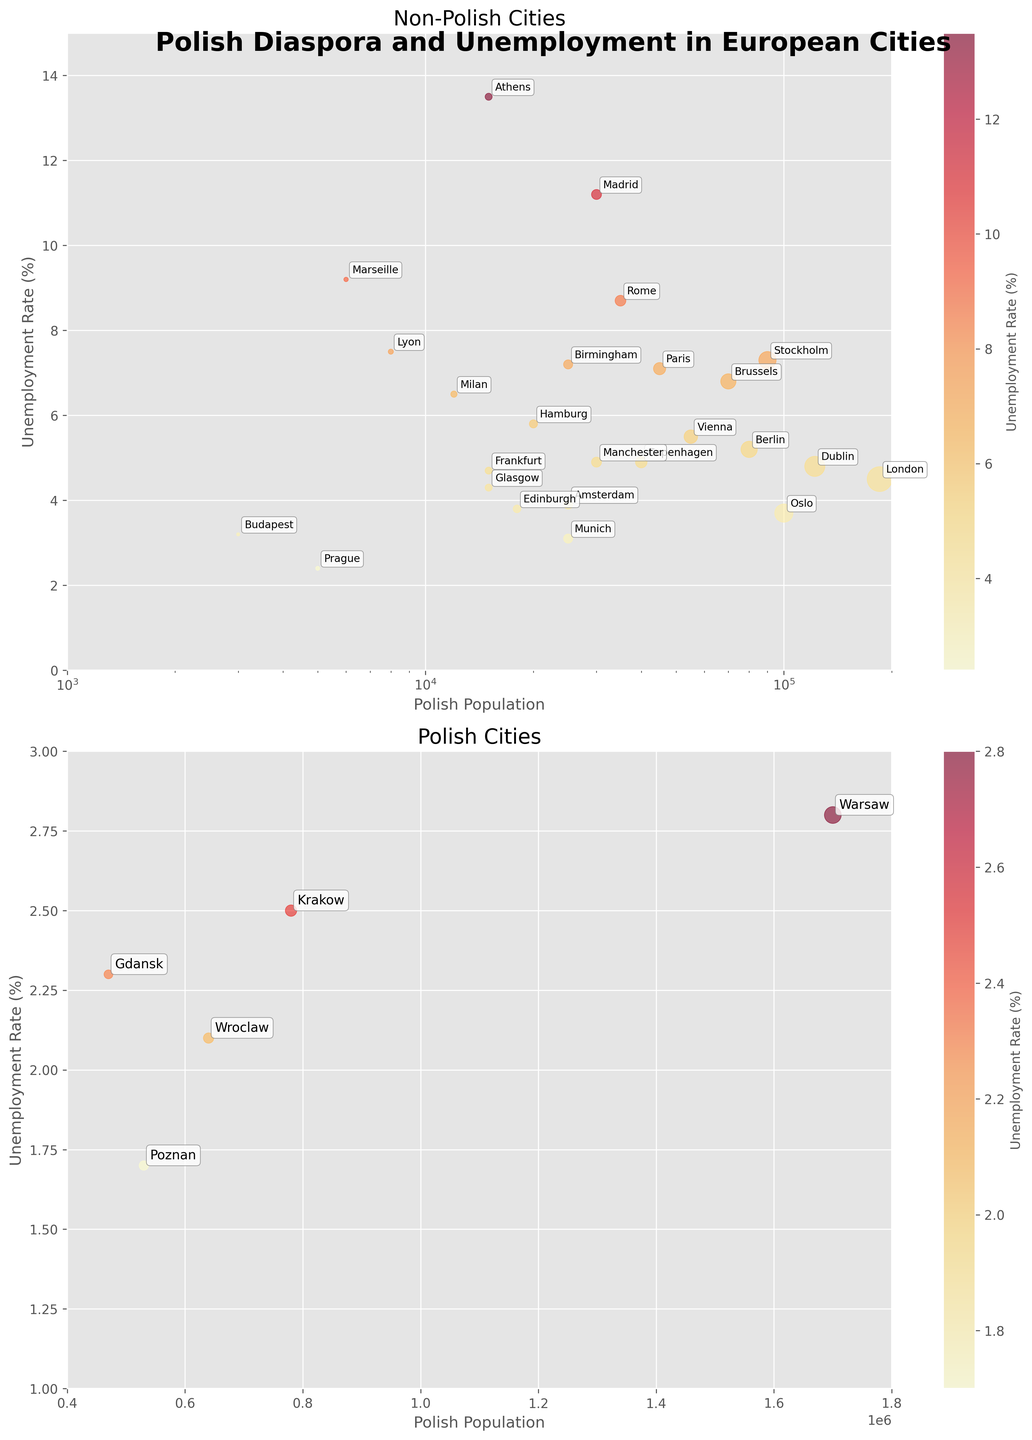What's the city with the highest Polish population outside of Poland? Refer to the non-Polish cities subplot. Notice the city with the largest circle among them, which corresponds to the highest Polish population. That city is London.
Answer: London Which city in Poland has the lowest unemployment rate? In the Polish cities subplot, find the city with the lowest position on the y-axis as this represents the lowest unemployment rate. The city is Poznan.
Answer: Poznan How does the unemployment rate in Berlin compare to that in Amsterdam? Look at the y-axis values for Berlin and Amsterdam in the non-Polish cities subplot. Berlin has an unemployment rate of 5.2%, while Amsterdam has 3.9%. Therefore, Berlin's rate is higher.
Answer: Berlin's rate is higher Is there any Polish city with an unemployment rate above 3%? Examine the Polish cities subplot. Notice that all city points lie within the range of 1-3% on the y-axis, indicating that none have an unemployment rate above 3%.
Answer: No Which city has the highest unemployment rate among non-Polish cities with a Polish population above 50,000? In the non-Polish cities subplot, identify cities above 50,000 on the x-axis. Among these, check the city with the highest position on the y-axis. The city is Athens with an unemployment rate of 13.5%.
Answer: Athens Compare the unemployment rates of Warsaw and Paris. Compare the y-axis values for Warsaw in the Polish cities subplot and Paris in the non-Polish cities subplot. Warsaw has an unemployment rate of 2.8%, while Paris has 7.1%. Therefore, Paris has a higher unemployment rate.
Answer: Paris has a higher rate What is the common unemployment rate range seen in non-Polish cities with a Polish population between 20,000 and 40,000? Focus on the non-Polish cities subplot, locating cities between 20,000 and 40,000 on the x-axis, and observe their distribution on the y-axis. Rates range from 3.8% (Edinburgh) to 5.8% (Hamburg).
Answer: 3.8% to 5.8% How many non-Polish cities have a higher unemployment rate than London? In the non-Polish cities subplot, London's unemployment rate is marked at 4.5%. Count the cities that have a point above this level on the y-axis. There are nine such cities.
Answer: 9 In terms of Polish population, which city is the closest to having 50,000 Poles in non-Polish cities? In the non-Polish cities subplot, locate the city with a circle closest to the 50,000 mark on the x-axis. The city is Stockholm with 90,000 Poles, relatively close to 50,000.
Answer: Stockholm 